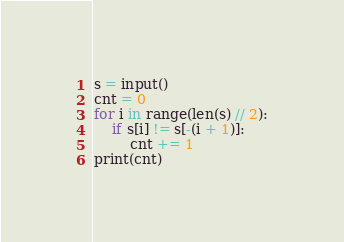<code> <loc_0><loc_0><loc_500><loc_500><_Python_>s = input()
cnt = 0
for i in range(len(s) // 2):
    if s[i] != s[-(i + 1)]:
        cnt += 1
print(cnt)</code> 